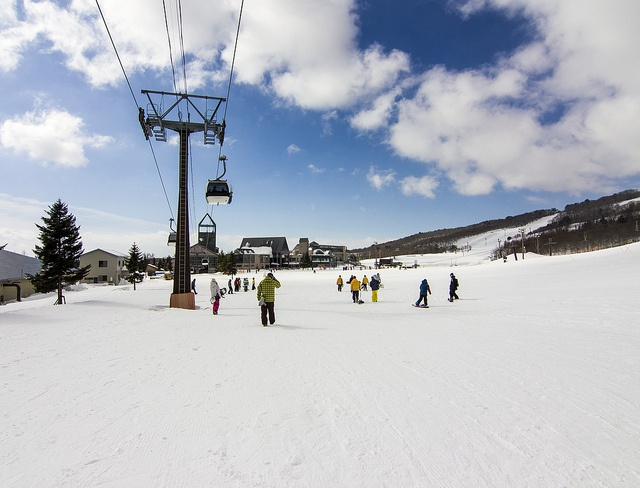Describe the objects in this image and their specific colors. I can see people in white, lightgray, black, gray, and darkgray tones, people in white, black, olive, and gray tones, people in white, black, lightgray, olive, and darkgray tones, people in white, black, navy, maroon, and teal tones, and people in white, black, olive, and gray tones in this image. 